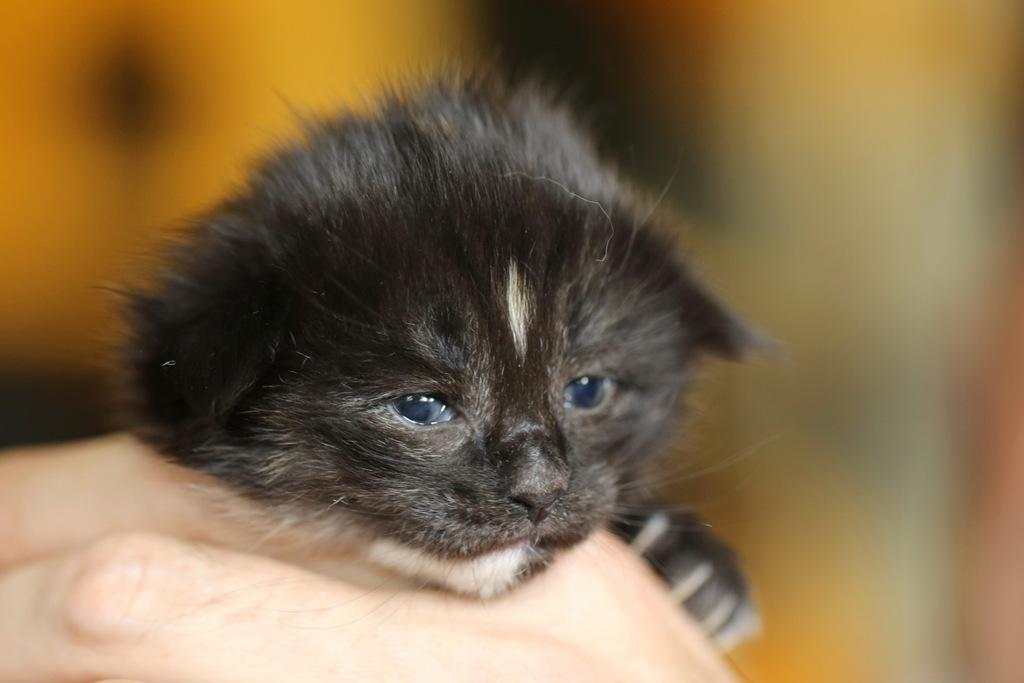What can be seen on the person's hand in the image? There is a small black cat on the hand. Can you describe the appearance of the cat? The cat is small and black. What can be observed about the background of the image? The background of the image is blurred. What type of texture can be seen on the throne in the image? There is no throne present in the image; it only features a person's hand with a small black cat on it. 